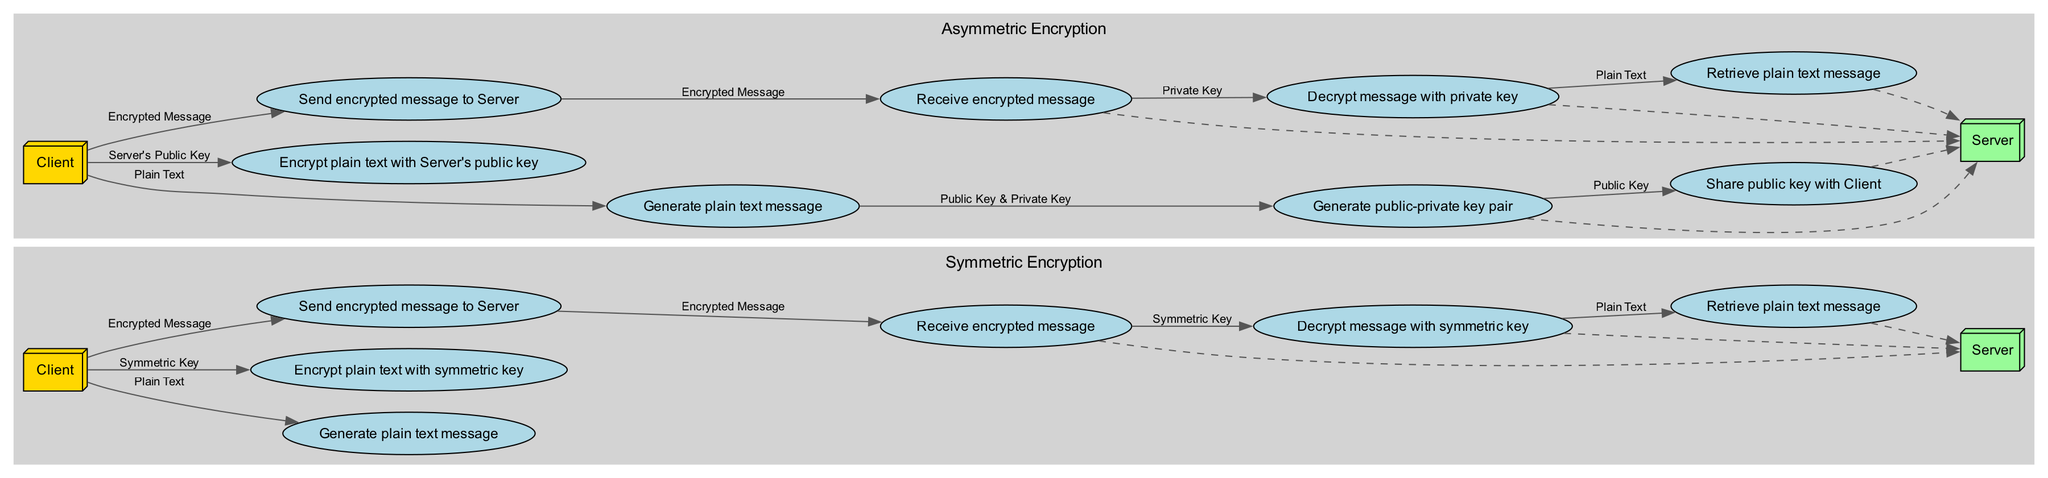What is the first step in symmetric encryption? The first step in symmetric encryption involves the Client generating a plain text message. This is indicated by the first step in the list of symmetric encryption steps.
Answer: Generate plain text message How many steps are in asymmetric encryption? In the asymmetric encryption section, there are eight steps listed. Therefore, counting each step from the data provided leads to a total of eight.
Answer: Eight What message does the Server send to the Client in asymmetric encryption? The Server shares the public key with the Client after generating a public-private key pair. This message is specified in the sequence of asymmetric encryption steps.
Answer: Share public key with Client Which encryption type involves a symmetric key? The encryption type that involves a symmetric key is symmetric encryption. The diagram explicitly states the use of symmetric keys in its steps.
Answer: Symmetric encryption How does the Client encrypt the plain text message in asymmetric encryption? The Client encrypts the plain text message using the Server's public key, as stated in the corresponding step of the asymmetric encryption process.
Answer: Encrypt plain text with Server's public key What does the Server use to decrypt the message in asymmetric encryption? The Server uses its private key to decrypt the received message. This is highlighted as a step in the asymmetric encryption flow.
Answer: Private Key What relationship exists between the Client and Server in symmetric encryption? In symmetric encryption, the Client sends the encrypted message to the Server, indicating a direct interaction that defines their relationship in this process.
Answer: Sends encrypted message to Server Which step occurs immediately after the Client generates plain text message in symmetric encryption? After generating the plain text message, the next step for the Client is to encrypt this plain text with the symmetric key. Thus, this is the immediate next step in the flow.
Answer: Encrypt plain text with symmetric key 